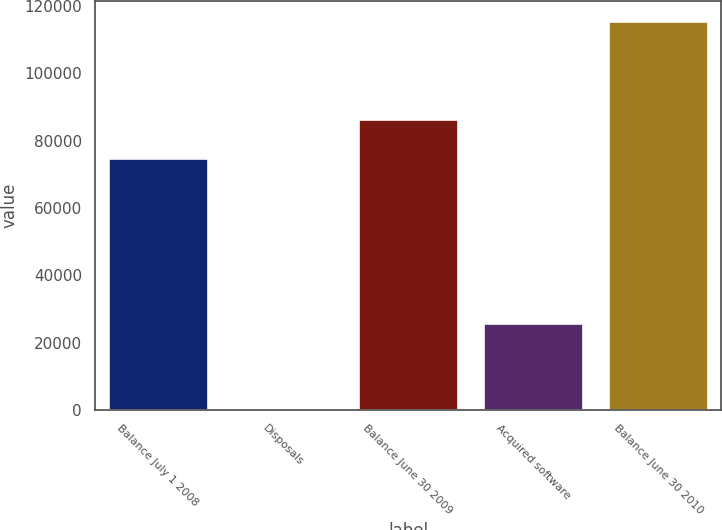Convert chart to OTSL. <chart><loc_0><loc_0><loc_500><loc_500><bar_chart><fcel>Balance July 1 2008<fcel>Disposals<fcel>Balance June 30 2009<fcel>Acquired software<fcel>Balance June 30 2010<nl><fcel>74943<fcel>28<fcel>86504.9<fcel>25931<fcel>115647<nl></chart> 